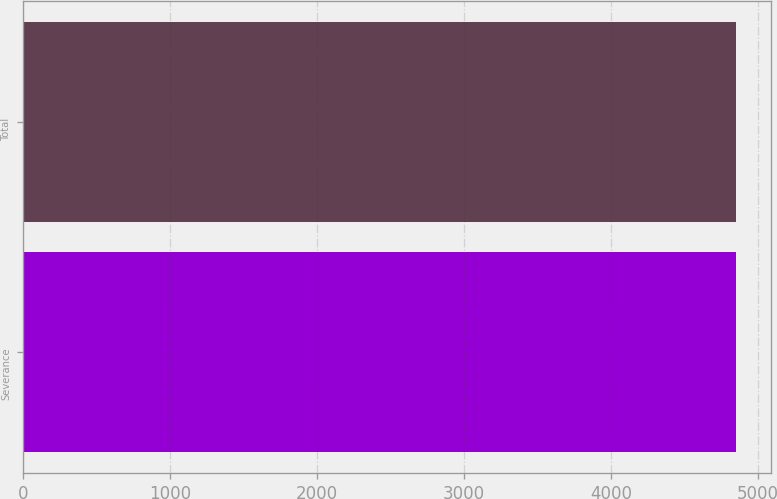Convert chart. <chart><loc_0><loc_0><loc_500><loc_500><bar_chart><fcel>Severance<fcel>Total<nl><fcel>4846<fcel>4846.1<nl></chart> 